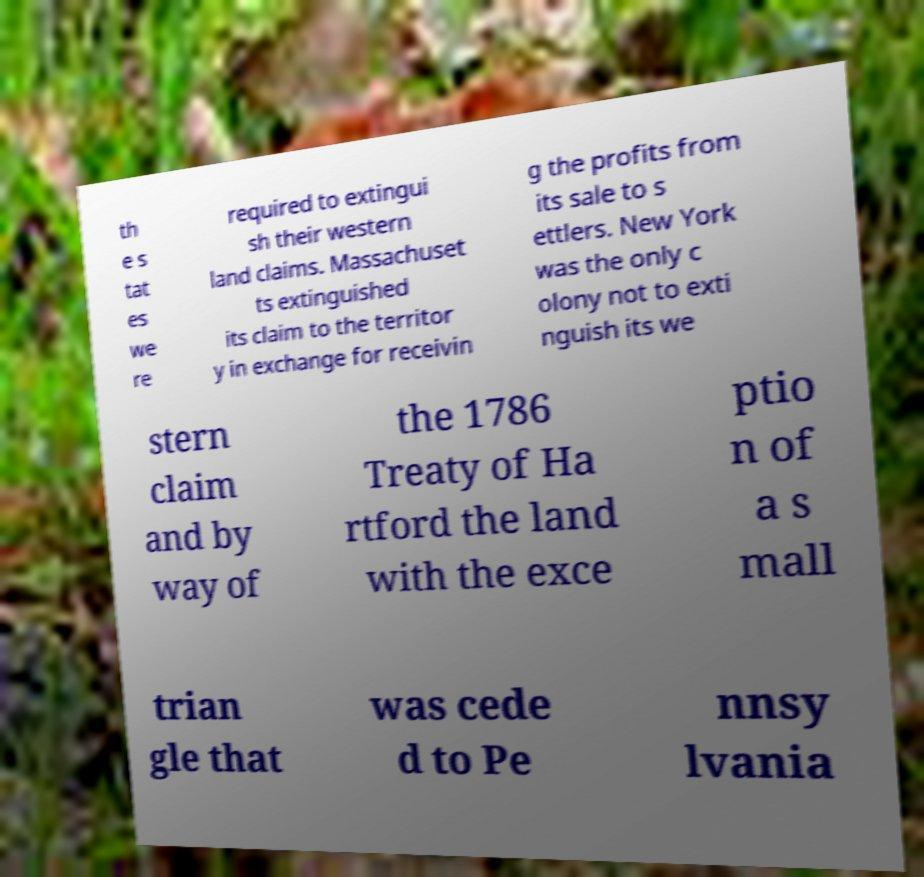Can you accurately transcribe the text from the provided image for me? th e s tat es we re required to extingui sh their western land claims. Massachuset ts extinguished its claim to the territor y in exchange for receivin g the profits from its sale to s ettlers. New York was the only c olony not to exti nguish its we stern claim and by way of the 1786 Treaty of Ha rtford the land with the exce ptio n of a s mall trian gle that was cede d to Pe nnsy lvania 